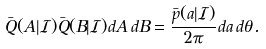Convert formula to latex. <formula><loc_0><loc_0><loc_500><loc_500>\bar { Q } ( A | \mathcal { I } ) \bar { Q } ( B | \mathcal { I } ) d A \, d B = \frac { \bar { p } ( a | \mathcal { I } ) } { 2 \pi } d a \, d \theta .</formula> 